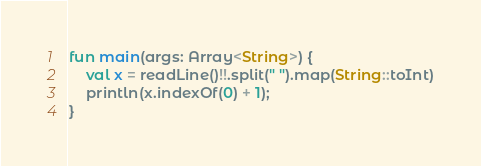Convert code to text. <code><loc_0><loc_0><loc_500><loc_500><_Kotlin_>fun main(args: Array<String>) {
    val x = readLine()!!.split(" ").map(String::toInt)
    println(x.indexOf(0) + 1);
}</code> 